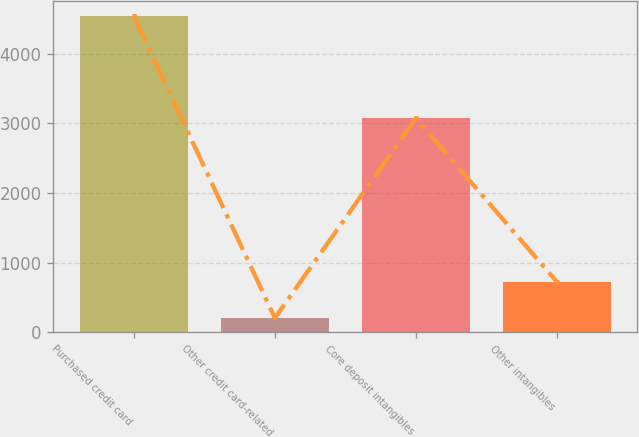Convert chart. <chart><loc_0><loc_0><loc_500><loc_500><bar_chart><fcel>Purchased credit card<fcel>Other credit card-related<fcel>Core deposit intangibles<fcel>Other intangibles<nl><fcel>4537<fcel>203<fcel>3073<fcel>723<nl></chart> 